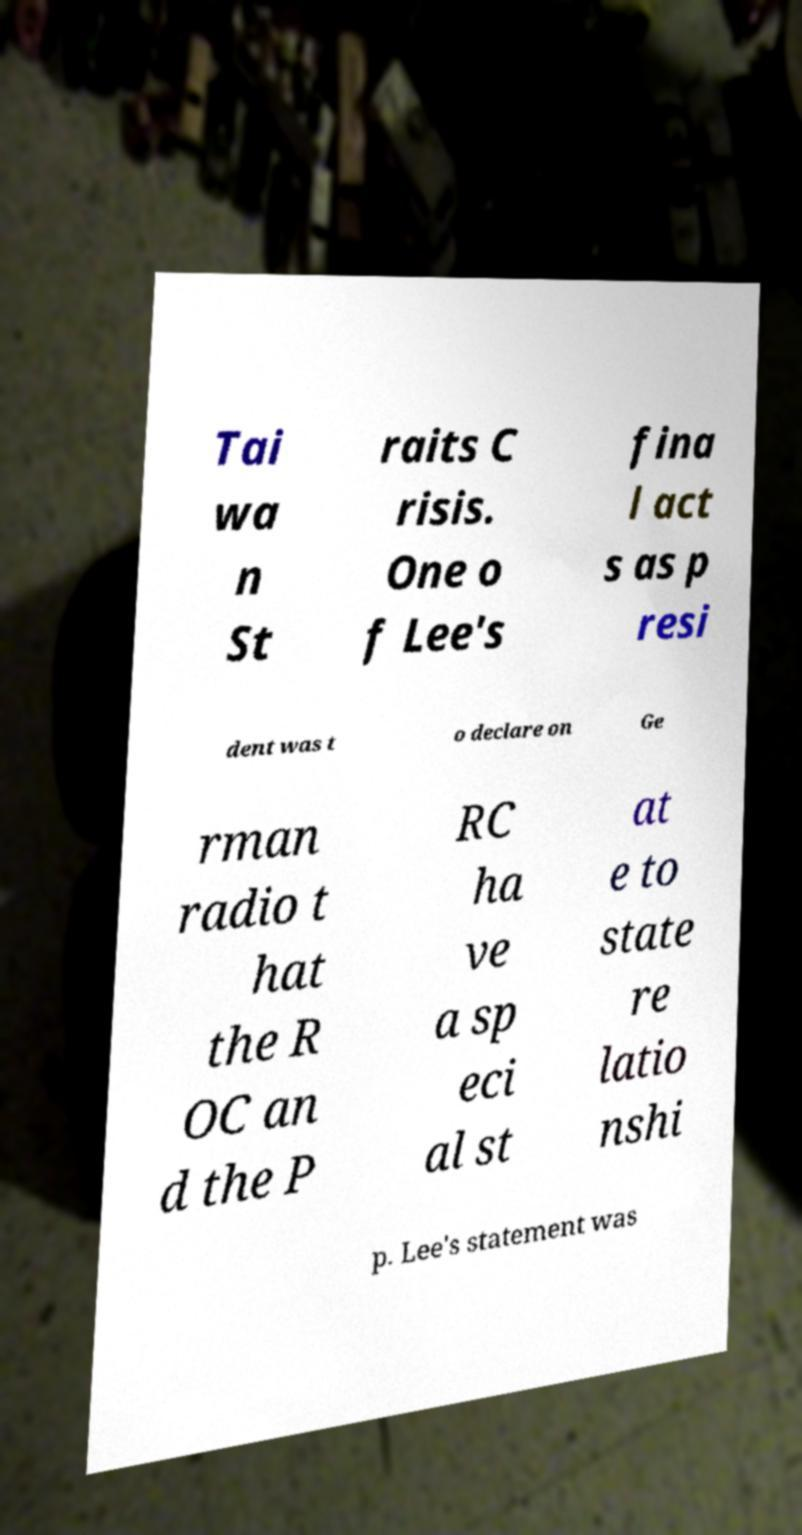For documentation purposes, I need the text within this image transcribed. Could you provide that? Tai wa n St raits C risis. One o f Lee's fina l act s as p resi dent was t o declare on Ge rman radio t hat the R OC an d the P RC ha ve a sp eci al st at e to state re latio nshi p. Lee's statement was 